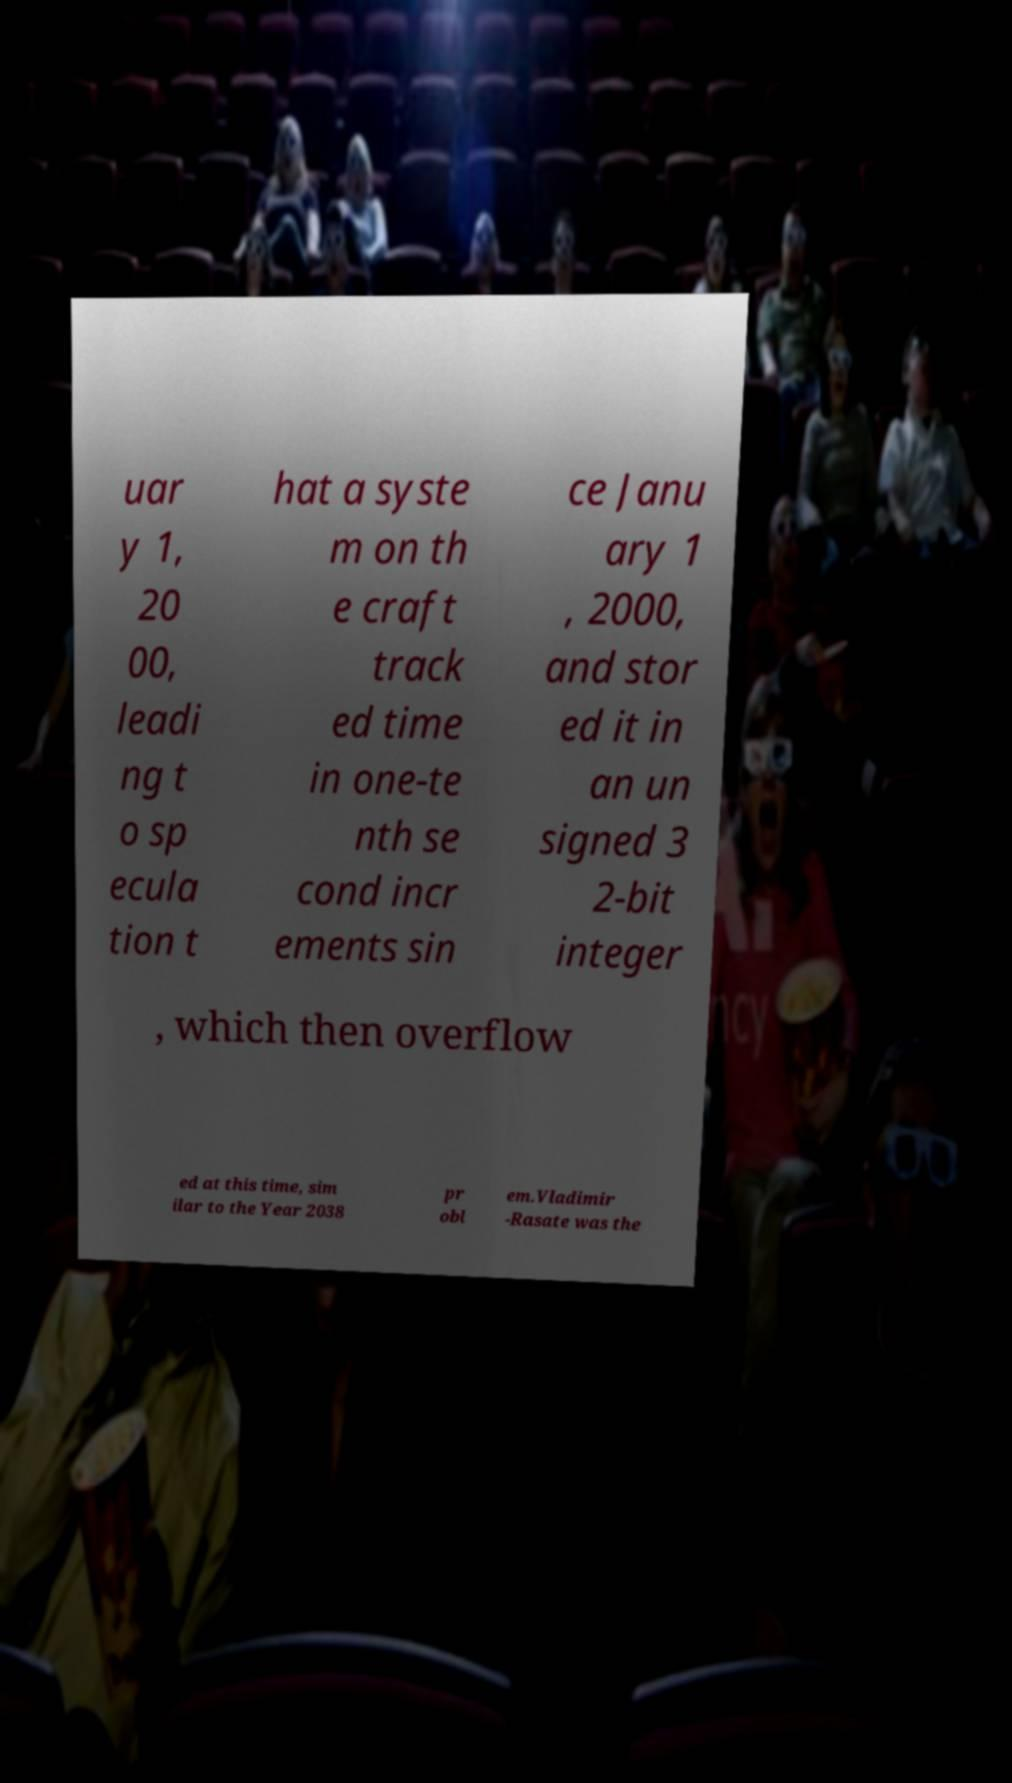Can you accurately transcribe the text from the provided image for me? uar y 1, 20 00, leadi ng t o sp ecula tion t hat a syste m on th e craft track ed time in one-te nth se cond incr ements sin ce Janu ary 1 , 2000, and stor ed it in an un signed 3 2-bit integer , which then overflow ed at this time, sim ilar to the Year 2038 pr obl em.Vladimir -Rasate was the 